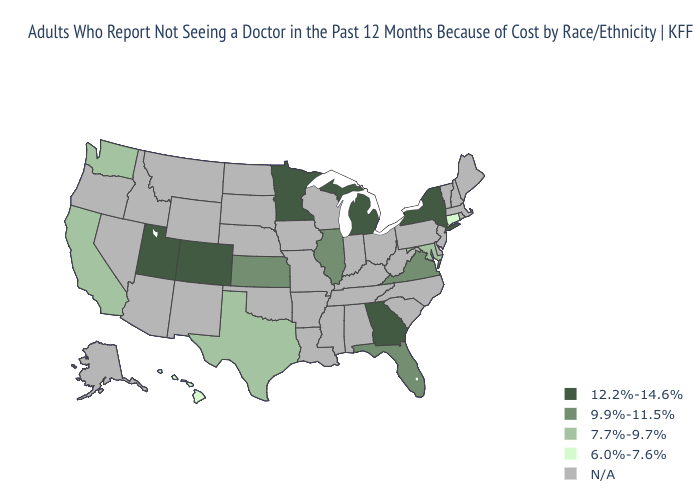Name the states that have a value in the range N/A?
Quick response, please. Alabama, Alaska, Arizona, Arkansas, Delaware, Idaho, Indiana, Iowa, Kentucky, Louisiana, Maine, Massachusetts, Mississippi, Missouri, Montana, Nebraska, Nevada, New Hampshire, New Jersey, New Mexico, North Carolina, North Dakota, Ohio, Oklahoma, Oregon, Pennsylvania, Rhode Island, South Carolina, South Dakota, Tennessee, Vermont, West Virginia, Wisconsin, Wyoming. Among the states that border Wyoming , which have the highest value?
Write a very short answer. Colorado, Utah. What is the highest value in the USA?
Keep it brief. 12.2%-14.6%. Among the states that border Louisiana , which have the lowest value?
Short answer required. Texas. What is the lowest value in the South?
Write a very short answer. 7.7%-9.7%. Does the first symbol in the legend represent the smallest category?
Write a very short answer. No. What is the value of Texas?
Answer briefly. 7.7%-9.7%. What is the lowest value in the South?
Keep it brief. 7.7%-9.7%. Name the states that have a value in the range 9.9%-11.5%?
Be succinct. Florida, Illinois, Kansas, Virginia. What is the value of Arizona?
Answer briefly. N/A. What is the value of Mississippi?
Keep it brief. N/A. What is the lowest value in the South?
Keep it brief. 7.7%-9.7%. Which states have the lowest value in the MidWest?
Keep it brief. Illinois, Kansas. Does Kansas have the highest value in the MidWest?
Answer briefly. No. 